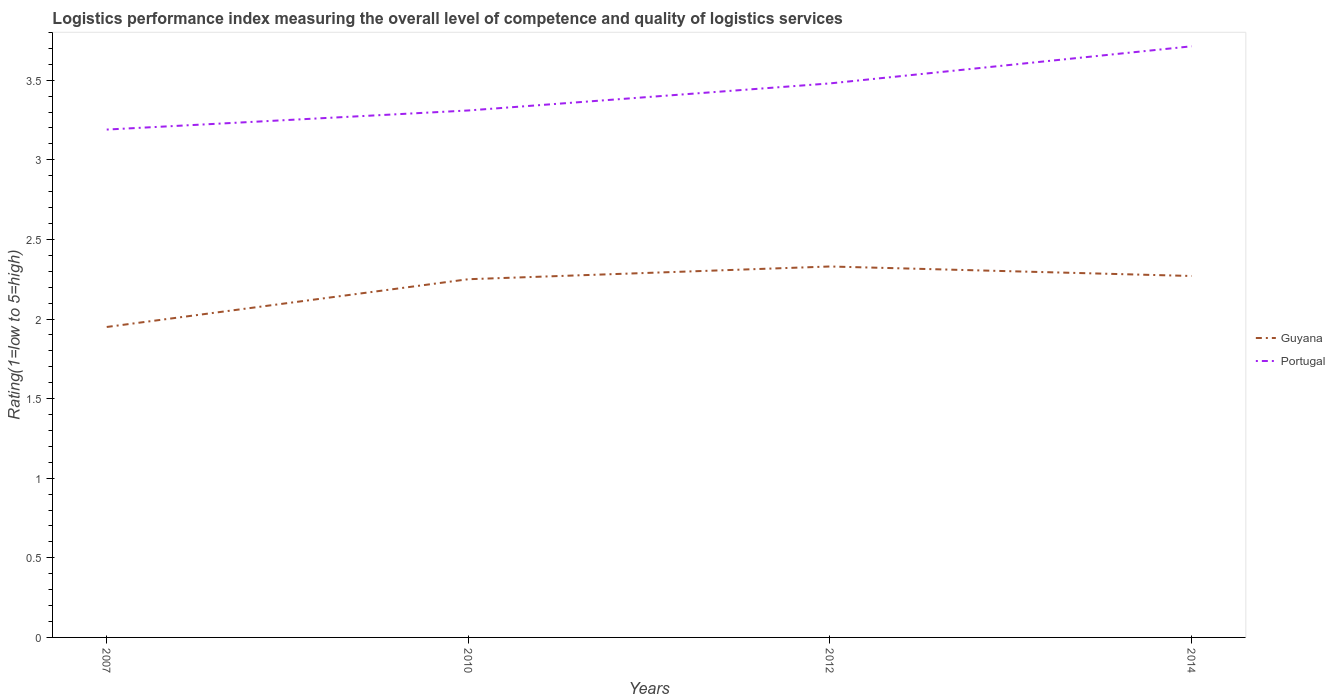How many different coloured lines are there?
Make the answer very short. 2. Does the line corresponding to Portugal intersect with the line corresponding to Guyana?
Offer a terse response. No. Is the number of lines equal to the number of legend labels?
Provide a short and direct response. Yes. Across all years, what is the maximum Logistic performance index in Guyana?
Give a very brief answer. 1.95. In which year was the Logistic performance index in Guyana maximum?
Offer a very short reply. 2007. What is the total Logistic performance index in Portugal in the graph?
Offer a terse response. -0.4. What is the difference between the highest and the second highest Logistic performance index in Guyana?
Your answer should be compact. 0.38. How many years are there in the graph?
Your response must be concise. 4. What is the difference between two consecutive major ticks on the Y-axis?
Keep it short and to the point. 0.5. Are the values on the major ticks of Y-axis written in scientific E-notation?
Provide a succinct answer. No. Does the graph contain any zero values?
Your answer should be very brief. No. Does the graph contain grids?
Provide a short and direct response. No. Where does the legend appear in the graph?
Your response must be concise. Center right. How many legend labels are there?
Provide a succinct answer. 2. What is the title of the graph?
Provide a succinct answer. Logistics performance index measuring the overall level of competence and quality of logistics services. What is the label or title of the Y-axis?
Offer a terse response. Rating(1=low to 5=high). What is the Rating(1=low to 5=high) in Guyana in 2007?
Make the answer very short. 1.95. What is the Rating(1=low to 5=high) of Portugal in 2007?
Your response must be concise. 3.19. What is the Rating(1=low to 5=high) in Guyana in 2010?
Offer a very short reply. 2.25. What is the Rating(1=low to 5=high) of Portugal in 2010?
Ensure brevity in your answer.  3.31. What is the Rating(1=low to 5=high) of Guyana in 2012?
Your answer should be compact. 2.33. What is the Rating(1=low to 5=high) of Portugal in 2012?
Ensure brevity in your answer.  3.48. What is the Rating(1=low to 5=high) in Guyana in 2014?
Keep it short and to the point. 2.27. What is the Rating(1=low to 5=high) of Portugal in 2014?
Your response must be concise. 3.71. Across all years, what is the maximum Rating(1=low to 5=high) in Guyana?
Provide a short and direct response. 2.33. Across all years, what is the maximum Rating(1=low to 5=high) of Portugal?
Ensure brevity in your answer.  3.71. Across all years, what is the minimum Rating(1=low to 5=high) of Guyana?
Keep it short and to the point. 1.95. Across all years, what is the minimum Rating(1=low to 5=high) of Portugal?
Make the answer very short. 3.19. What is the total Rating(1=low to 5=high) in Guyana in the graph?
Your response must be concise. 8.8. What is the total Rating(1=low to 5=high) of Portugal in the graph?
Ensure brevity in your answer.  13.69. What is the difference between the Rating(1=low to 5=high) in Guyana in 2007 and that in 2010?
Give a very brief answer. -0.3. What is the difference between the Rating(1=low to 5=high) of Portugal in 2007 and that in 2010?
Give a very brief answer. -0.12. What is the difference between the Rating(1=low to 5=high) of Guyana in 2007 and that in 2012?
Offer a terse response. -0.38. What is the difference between the Rating(1=low to 5=high) of Portugal in 2007 and that in 2012?
Make the answer very short. -0.29. What is the difference between the Rating(1=low to 5=high) of Guyana in 2007 and that in 2014?
Ensure brevity in your answer.  -0.32. What is the difference between the Rating(1=low to 5=high) of Portugal in 2007 and that in 2014?
Offer a very short reply. -0.52. What is the difference between the Rating(1=low to 5=high) in Guyana in 2010 and that in 2012?
Your response must be concise. -0.08. What is the difference between the Rating(1=low to 5=high) in Portugal in 2010 and that in 2012?
Your response must be concise. -0.17. What is the difference between the Rating(1=low to 5=high) of Guyana in 2010 and that in 2014?
Provide a short and direct response. -0.02. What is the difference between the Rating(1=low to 5=high) of Portugal in 2010 and that in 2014?
Make the answer very short. -0.4. What is the difference between the Rating(1=low to 5=high) in Guyana in 2012 and that in 2014?
Ensure brevity in your answer.  0.06. What is the difference between the Rating(1=low to 5=high) in Portugal in 2012 and that in 2014?
Your answer should be compact. -0.23. What is the difference between the Rating(1=low to 5=high) in Guyana in 2007 and the Rating(1=low to 5=high) in Portugal in 2010?
Offer a terse response. -1.36. What is the difference between the Rating(1=low to 5=high) of Guyana in 2007 and the Rating(1=low to 5=high) of Portugal in 2012?
Ensure brevity in your answer.  -1.53. What is the difference between the Rating(1=low to 5=high) in Guyana in 2007 and the Rating(1=low to 5=high) in Portugal in 2014?
Give a very brief answer. -1.76. What is the difference between the Rating(1=low to 5=high) in Guyana in 2010 and the Rating(1=low to 5=high) in Portugal in 2012?
Your answer should be very brief. -1.23. What is the difference between the Rating(1=low to 5=high) of Guyana in 2010 and the Rating(1=low to 5=high) of Portugal in 2014?
Your answer should be compact. -1.46. What is the difference between the Rating(1=low to 5=high) of Guyana in 2012 and the Rating(1=low to 5=high) of Portugal in 2014?
Keep it short and to the point. -1.38. What is the average Rating(1=low to 5=high) in Guyana per year?
Offer a very short reply. 2.2. What is the average Rating(1=low to 5=high) in Portugal per year?
Make the answer very short. 3.42. In the year 2007, what is the difference between the Rating(1=low to 5=high) of Guyana and Rating(1=low to 5=high) of Portugal?
Your answer should be compact. -1.24. In the year 2010, what is the difference between the Rating(1=low to 5=high) in Guyana and Rating(1=low to 5=high) in Portugal?
Your answer should be very brief. -1.06. In the year 2012, what is the difference between the Rating(1=low to 5=high) of Guyana and Rating(1=low to 5=high) of Portugal?
Make the answer very short. -1.15. In the year 2014, what is the difference between the Rating(1=low to 5=high) in Guyana and Rating(1=low to 5=high) in Portugal?
Your answer should be compact. -1.44. What is the ratio of the Rating(1=low to 5=high) of Guyana in 2007 to that in 2010?
Keep it short and to the point. 0.87. What is the ratio of the Rating(1=low to 5=high) in Portugal in 2007 to that in 2010?
Your answer should be compact. 0.96. What is the ratio of the Rating(1=low to 5=high) of Guyana in 2007 to that in 2012?
Keep it short and to the point. 0.84. What is the ratio of the Rating(1=low to 5=high) of Portugal in 2007 to that in 2012?
Provide a short and direct response. 0.92. What is the ratio of the Rating(1=low to 5=high) in Guyana in 2007 to that in 2014?
Offer a terse response. 0.86. What is the ratio of the Rating(1=low to 5=high) in Portugal in 2007 to that in 2014?
Offer a terse response. 0.86. What is the ratio of the Rating(1=low to 5=high) of Guyana in 2010 to that in 2012?
Ensure brevity in your answer.  0.97. What is the ratio of the Rating(1=low to 5=high) of Portugal in 2010 to that in 2012?
Provide a short and direct response. 0.95. What is the ratio of the Rating(1=low to 5=high) of Portugal in 2010 to that in 2014?
Offer a very short reply. 0.89. What is the ratio of the Rating(1=low to 5=high) of Guyana in 2012 to that in 2014?
Make the answer very short. 1.03. What is the ratio of the Rating(1=low to 5=high) in Portugal in 2012 to that in 2014?
Give a very brief answer. 0.94. What is the difference between the highest and the second highest Rating(1=low to 5=high) of Guyana?
Offer a terse response. 0.06. What is the difference between the highest and the second highest Rating(1=low to 5=high) in Portugal?
Keep it short and to the point. 0.23. What is the difference between the highest and the lowest Rating(1=low to 5=high) of Guyana?
Ensure brevity in your answer.  0.38. What is the difference between the highest and the lowest Rating(1=low to 5=high) in Portugal?
Offer a very short reply. 0.52. 